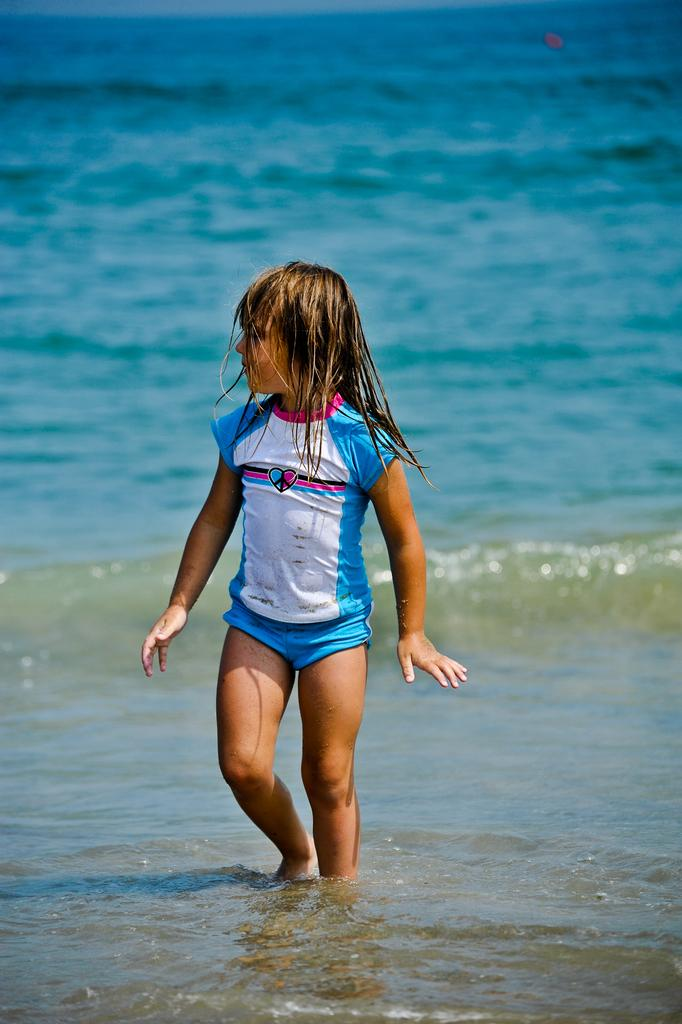Who is the main subject in the image? There is a small girl in the image. What is the girl wearing? The girl is wearing a blue dress. Where is the girl standing? The girl is standing in the sea water. What direction is the girl looking? The girl is looking to the left side. What can be seen in the background of the image? There is blue water visible in the background. What type of coat is the girl wearing in the image? The girl is not wearing a coat in the image; she is wearing a blue dress. What reward is the girl receiving for her actions in the image? There is no indication in the image that the girl is receiving a reward for any actions. 